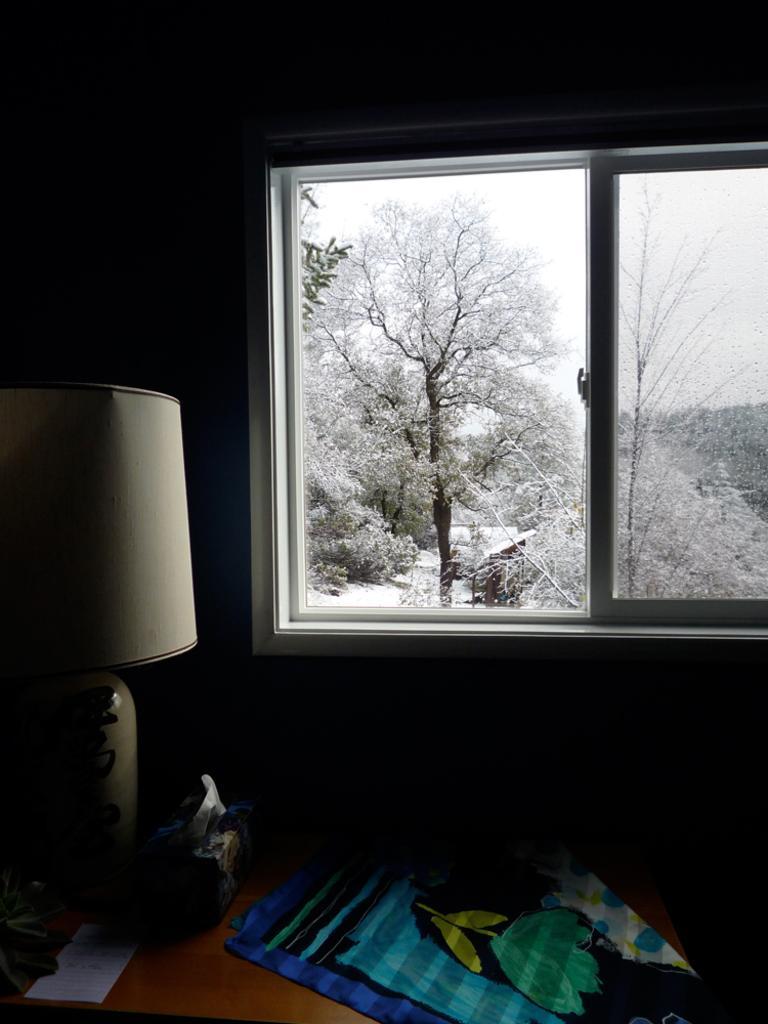Describe this image in one or two sentences. In this image I can see a brown colored table on which I can see a cloth which is blue, green and yellow in color, a lamp which is white in color, a paper and few other objects. I can see a window through which I can see few trees and the sky. 